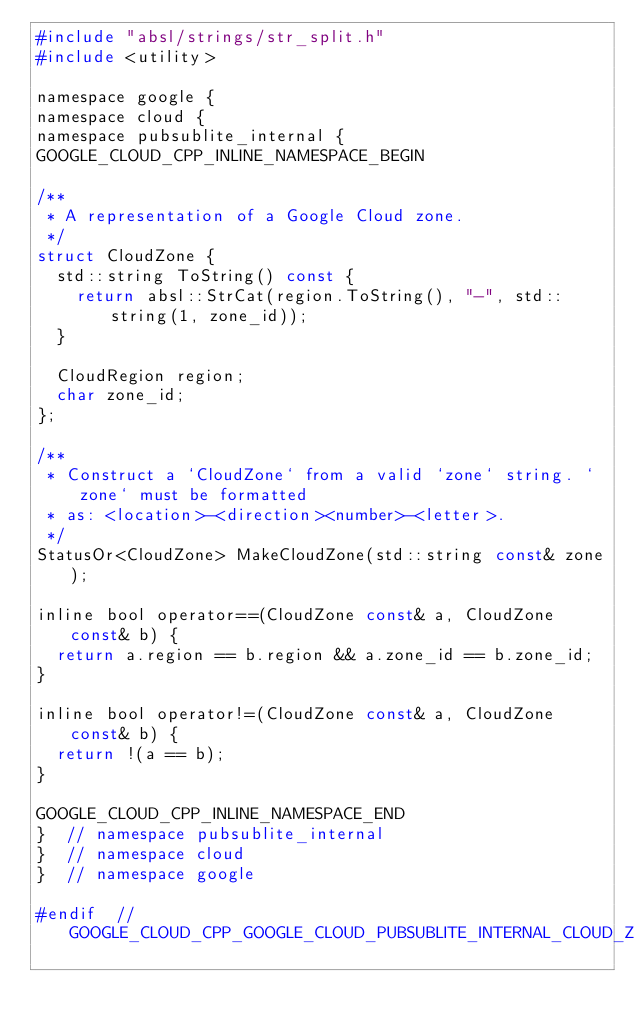<code> <loc_0><loc_0><loc_500><loc_500><_C_>#include "absl/strings/str_split.h"
#include <utility>

namespace google {
namespace cloud {
namespace pubsublite_internal {
GOOGLE_CLOUD_CPP_INLINE_NAMESPACE_BEGIN

/**
 * A representation of a Google Cloud zone.
 */
struct CloudZone {
  std::string ToString() const {
    return absl::StrCat(region.ToString(), "-", std::string(1, zone_id));
  }

  CloudRegion region;
  char zone_id;
};

/**
 * Construct a `CloudZone` from a valid `zone` string. `zone` must be formatted
 * as: <location>-<direction><number>-<letter>.
 */
StatusOr<CloudZone> MakeCloudZone(std::string const& zone);

inline bool operator==(CloudZone const& a, CloudZone const& b) {
  return a.region == b.region && a.zone_id == b.zone_id;
}

inline bool operator!=(CloudZone const& a, CloudZone const& b) {
  return !(a == b);
}

GOOGLE_CLOUD_CPP_INLINE_NAMESPACE_END
}  // namespace pubsublite_internal
}  // namespace cloud
}  // namespace google

#endif  // GOOGLE_CLOUD_CPP_GOOGLE_CLOUD_PUBSUBLITE_INTERNAL_CLOUD_ZONE_H
</code> 